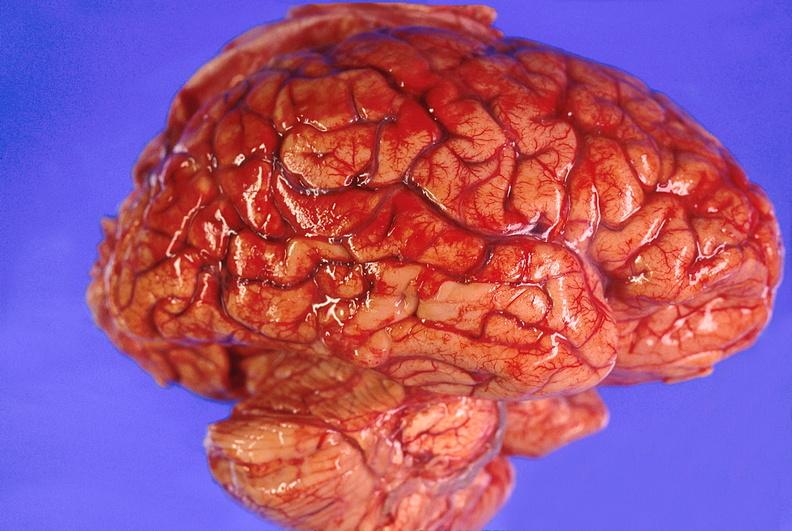does this image show brain abscess?
Answer the question using a single word or phrase. Yes 